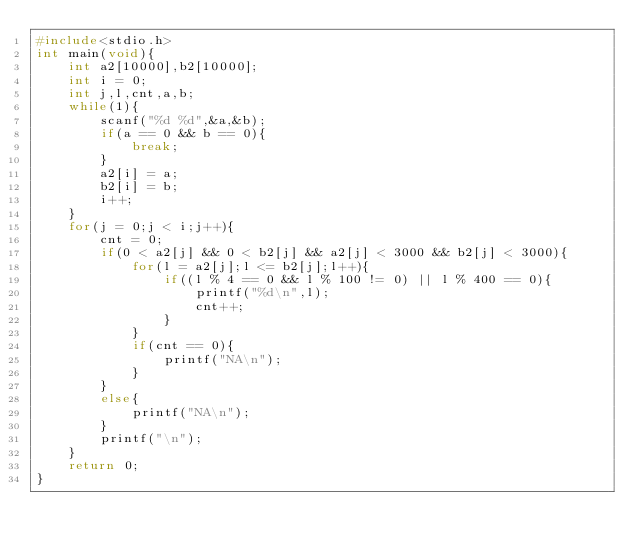Convert code to text. <code><loc_0><loc_0><loc_500><loc_500><_C_>#include<stdio.h>
int main(void){
    int a2[10000],b2[10000];
    int i = 0;
    int j,l,cnt,a,b;
    while(1){
        scanf("%d %d",&a,&b);
        if(a == 0 && b == 0){
            break;
        }
        a2[i] = a;
        b2[i] = b;
        i++;
    }
    for(j = 0;j < i;j++){
        cnt = 0;
        if(0 < a2[j] && 0 < b2[j] && a2[j] < 3000 && b2[j] < 3000){
            for(l = a2[j];l <= b2[j];l++){
                if((l % 4 == 0 && l % 100 != 0) || l % 400 == 0){
                    printf("%d\n",l);
                    cnt++;
                }
            }
            if(cnt == 0){
                printf("NA\n");
            }
        }
        else{
            printf("NA\n");
        }
        printf("\n");
    }
    return 0;
}</code> 